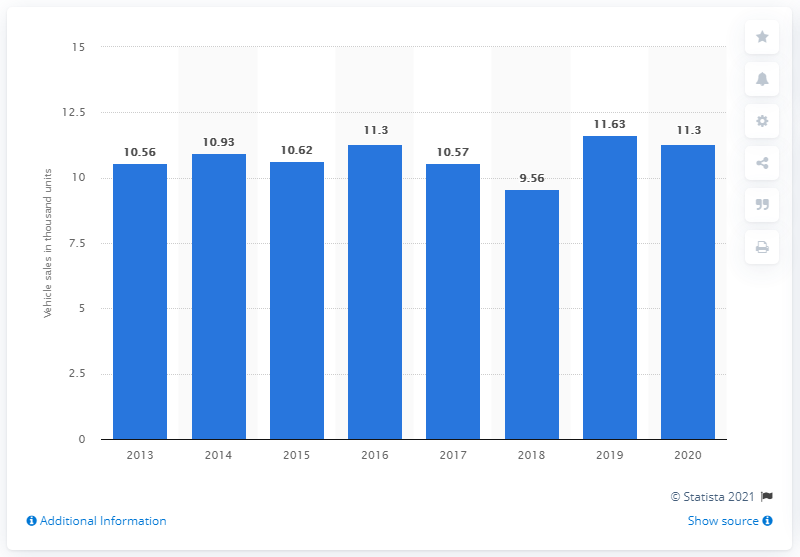Specify some key components in this picture. The timeline provides a comprehensive overview of Bentley's global vehicle sales from 2013 to 2020. In 2013, Bentley reported its worldwide vehicle sales for the first time. 